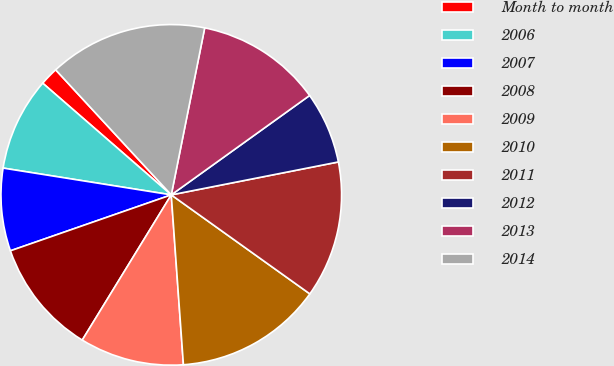<chart> <loc_0><loc_0><loc_500><loc_500><pie_chart><fcel>Month to month<fcel>2006<fcel>2007<fcel>2008<fcel>2009<fcel>2010<fcel>2011<fcel>2012<fcel>2013<fcel>2014<nl><fcel>1.74%<fcel>8.87%<fcel>7.84%<fcel>10.92%<fcel>9.89%<fcel>13.99%<fcel>12.97%<fcel>6.82%<fcel>11.94%<fcel>15.02%<nl></chart> 